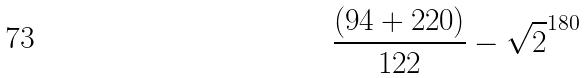<formula> <loc_0><loc_0><loc_500><loc_500>\frac { ( 9 4 + 2 2 0 ) } { 1 2 2 } - \sqrt { 2 } ^ { 1 8 0 }</formula> 